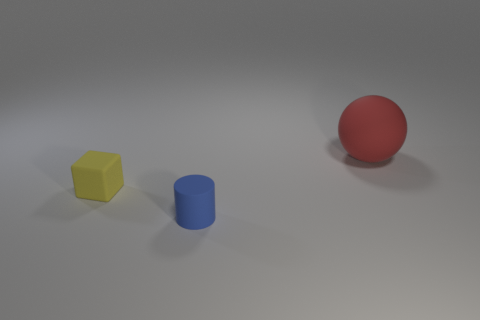Subtract all brown cubes. Subtract all purple balls. How many cubes are left? 1 Add 3 small cylinders. How many objects exist? 6 Subtract all cylinders. How many objects are left? 2 Subtract all big red matte objects. Subtract all tiny cylinders. How many objects are left? 1 Add 3 red rubber things. How many red rubber things are left? 4 Add 1 big matte spheres. How many big matte spheres exist? 2 Subtract 0 cyan blocks. How many objects are left? 3 